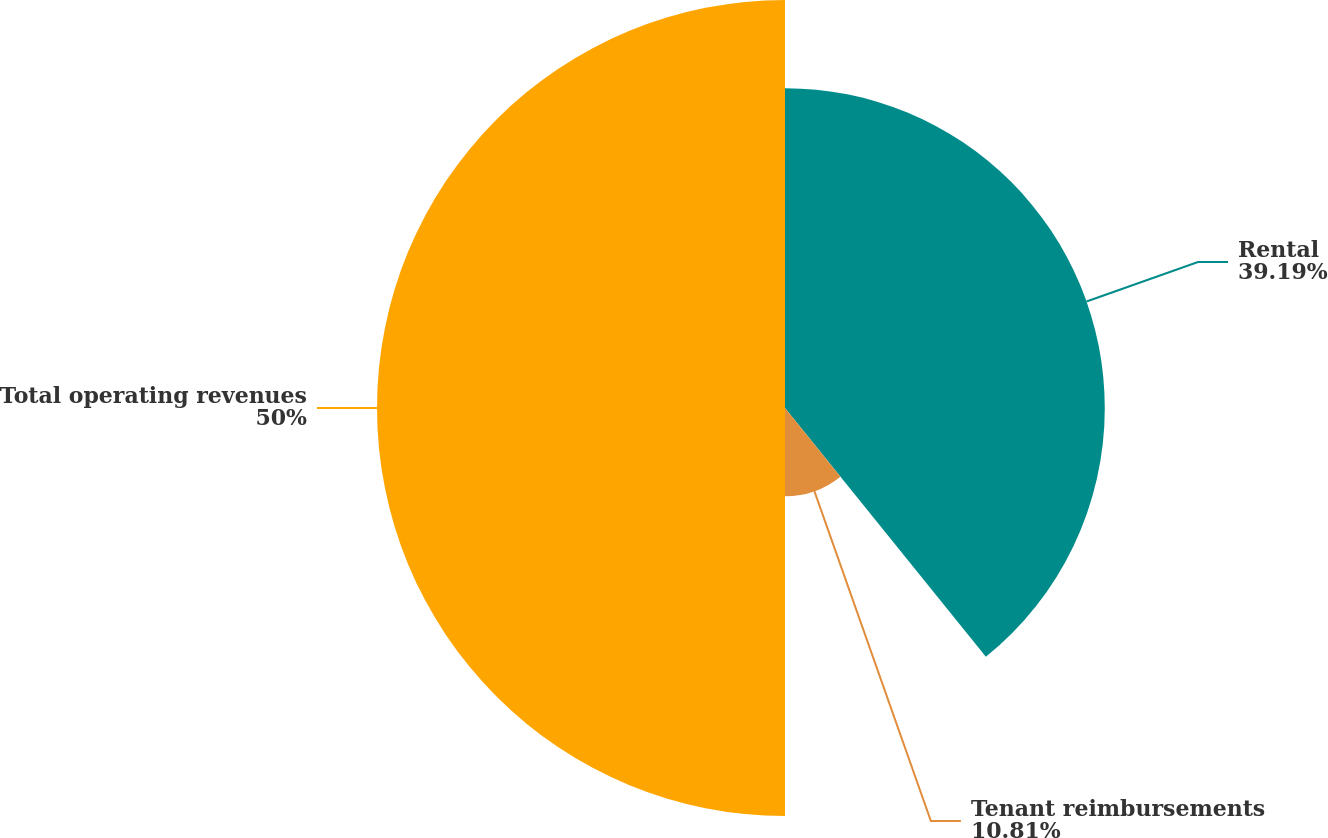<chart> <loc_0><loc_0><loc_500><loc_500><pie_chart><fcel>Rental<fcel>Tenant reimbursements<fcel>Total operating revenues<nl><fcel>39.19%<fcel>10.81%<fcel>50.0%<nl></chart> 